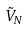<formula> <loc_0><loc_0><loc_500><loc_500>\tilde { V } _ { N }</formula> 